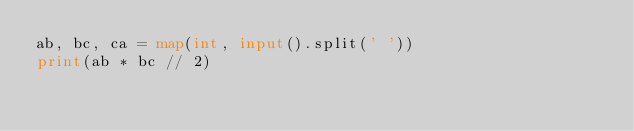<code> <loc_0><loc_0><loc_500><loc_500><_Python_>ab, bc, ca = map(int, input().split(' '))
print(ab * bc // 2)</code> 